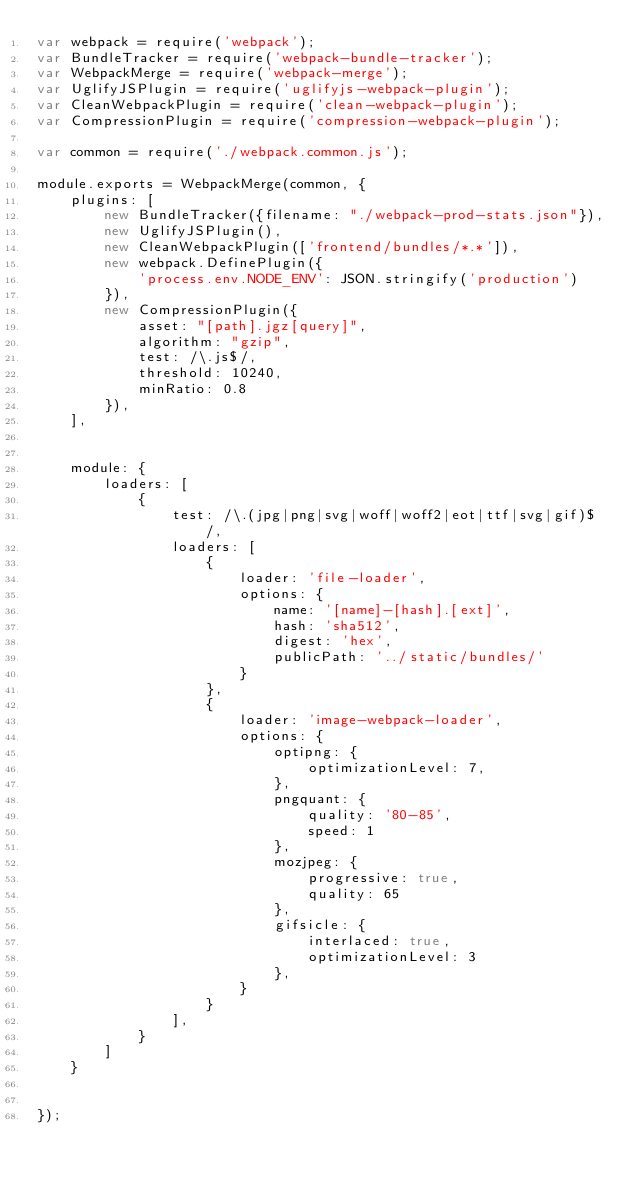<code> <loc_0><loc_0><loc_500><loc_500><_JavaScript_>var webpack = require('webpack');
var BundleTracker = require('webpack-bundle-tracker');
var WebpackMerge = require('webpack-merge');
var UglifyJSPlugin = require('uglifyjs-webpack-plugin');
var CleanWebpackPlugin = require('clean-webpack-plugin');
var CompressionPlugin = require('compression-webpack-plugin');

var common = require('./webpack.common.js');

module.exports = WebpackMerge(common, {
    plugins: [
        new BundleTracker({filename: "./webpack-prod-stats.json"}),
        new UglifyJSPlugin(),
        new CleanWebpackPlugin(['frontend/bundles/*.*']),
        new webpack.DefinePlugin({
            'process.env.NODE_ENV': JSON.stringify('production')
        }),
        new CompressionPlugin({
            asset: "[path].jgz[query]",
            algorithm: "gzip",
            test: /\.js$/,
            threshold: 10240,
            minRatio: 0.8
        }),
    ],


    module: {
        loaders: [
            {
                test: /\.(jpg|png|svg|woff|woff2|eot|ttf|svg|gif)$/,
                loaders: [
                    {
                        loader: 'file-loader',
                        options: {
                            name: '[name]-[hash].[ext]',
                            hash: 'sha512',
                            digest: 'hex',
                            publicPath: '../static/bundles/'
                        }
                    },
                    {
                        loader: 'image-webpack-loader',
                        options: {
                            optipng: {
                                optimizationLevel: 7,
                            },
                            pngquant: {
                                quality: '80-85',
                                speed: 1
                            },
                            mozjpeg: {
                                progressive: true,
                                quality: 65
                            },
                            gifsicle: {
                                interlaced: true,
                                optimizationLevel: 3
                            },
                        }
                    }
                ],
            }
        ]
    }


});</code> 